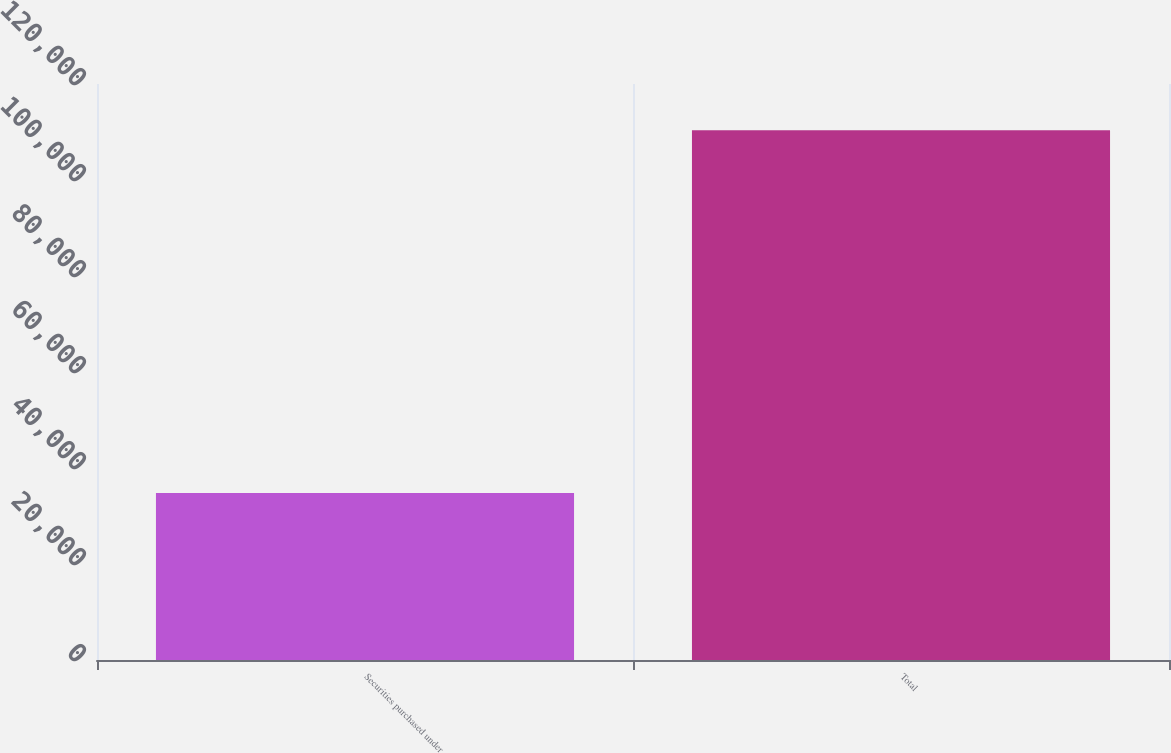Convert chart. <chart><loc_0><loc_0><loc_500><loc_500><bar_chart><fcel>Securities purchased under<fcel>Total<nl><fcel>34807<fcel>110361<nl></chart> 